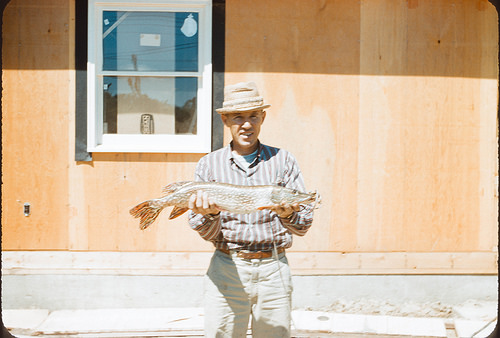<image>
Is there a hat in front of the man? No. The hat is not in front of the man. The spatial positioning shows a different relationship between these objects. 